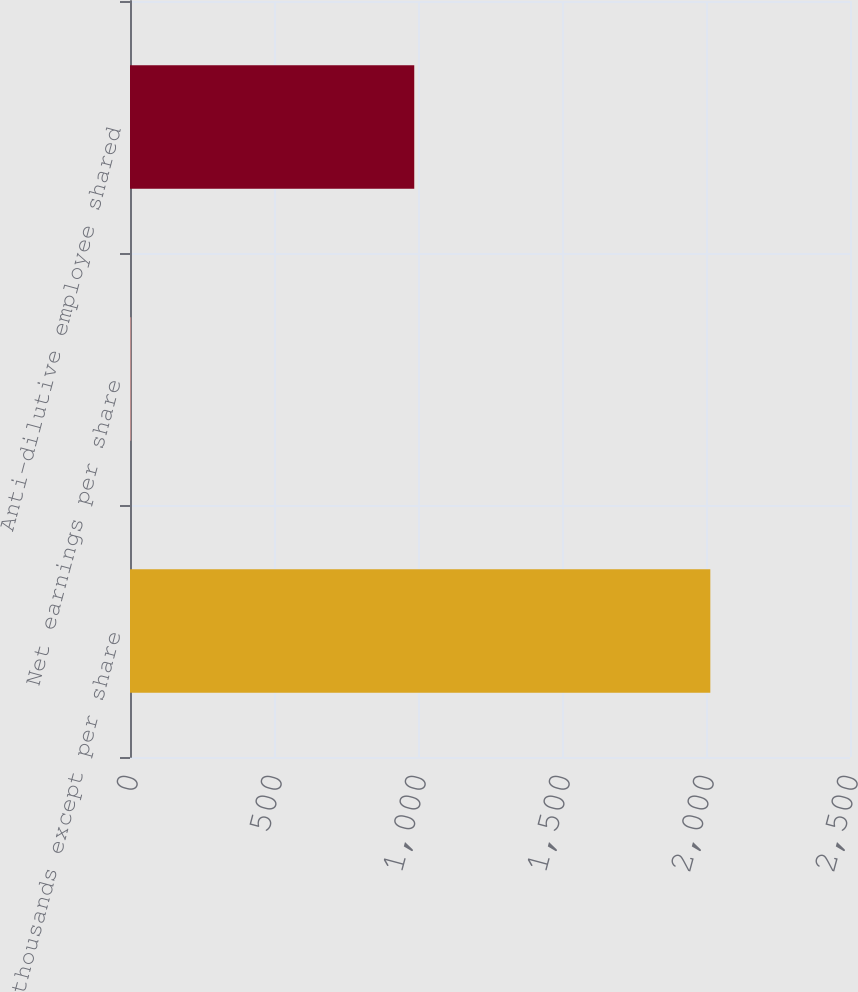<chart> <loc_0><loc_0><loc_500><loc_500><bar_chart><fcel>(In thousands except per share<fcel>Net earnings per share<fcel>Anti-dilutive employee shared<nl><fcel>2015<fcel>4.09<fcel>987<nl></chart> 